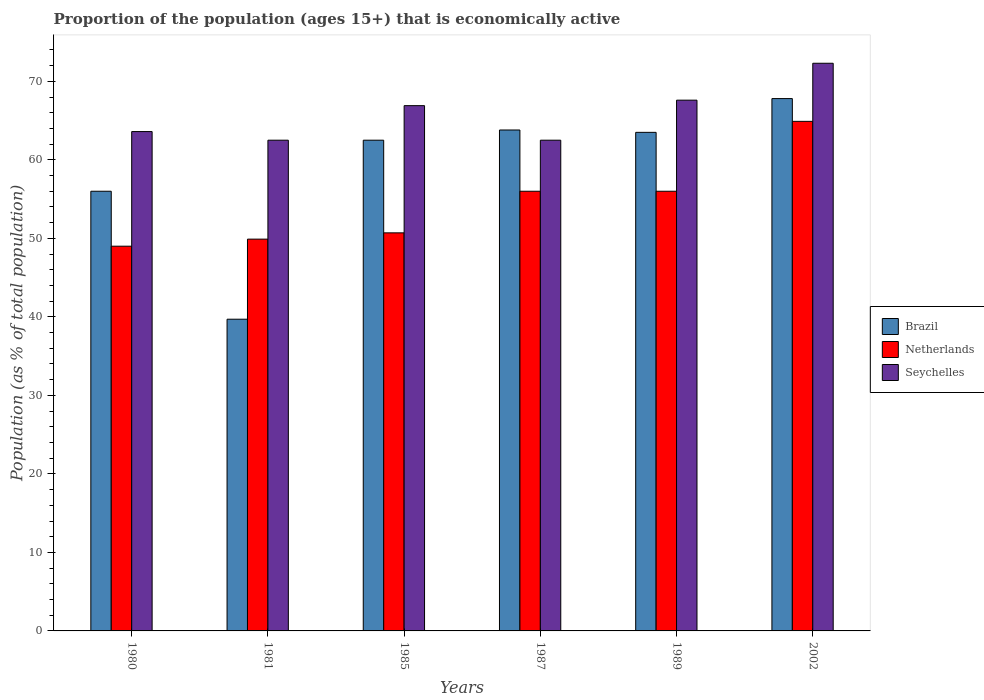How many different coloured bars are there?
Make the answer very short. 3. How many groups of bars are there?
Make the answer very short. 6. Are the number of bars per tick equal to the number of legend labels?
Offer a terse response. Yes. How many bars are there on the 3rd tick from the left?
Give a very brief answer. 3. How many bars are there on the 6th tick from the right?
Keep it short and to the point. 3. In how many cases, is the number of bars for a given year not equal to the number of legend labels?
Give a very brief answer. 0. What is the proportion of the population that is economically active in Seychelles in 1987?
Your answer should be very brief. 62.5. Across all years, what is the maximum proportion of the population that is economically active in Seychelles?
Provide a succinct answer. 72.3. Across all years, what is the minimum proportion of the population that is economically active in Netherlands?
Offer a terse response. 49. In which year was the proportion of the population that is economically active in Netherlands maximum?
Offer a very short reply. 2002. What is the total proportion of the population that is economically active in Netherlands in the graph?
Offer a terse response. 326.5. What is the difference between the proportion of the population that is economically active in Netherlands in 1980 and that in 1985?
Offer a terse response. -1.7. What is the difference between the proportion of the population that is economically active in Brazil in 1981 and the proportion of the population that is economically active in Netherlands in 2002?
Keep it short and to the point. -25.2. What is the average proportion of the population that is economically active in Brazil per year?
Give a very brief answer. 58.88. In the year 2002, what is the difference between the proportion of the population that is economically active in Seychelles and proportion of the population that is economically active in Brazil?
Ensure brevity in your answer.  4.5. In how many years, is the proportion of the population that is economically active in Brazil greater than 50 %?
Ensure brevity in your answer.  5. Is the difference between the proportion of the population that is economically active in Seychelles in 1980 and 1981 greater than the difference between the proportion of the population that is economically active in Brazil in 1980 and 1981?
Provide a succinct answer. No. What is the difference between the highest and the second highest proportion of the population that is economically active in Seychelles?
Your answer should be very brief. 4.7. What is the difference between the highest and the lowest proportion of the population that is economically active in Netherlands?
Provide a short and direct response. 15.9. In how many years, is the proportion of the population that is economically active in Netherlands greater than the average proportion of the population that is economically active in Netherlands taken over all years?
Your answer should be very brief. 3. Is the sum of the proportion of the population that is economically active in Brazil in 1985 and 1989 greater than the maximum proportion of the population that is economically active in Seychelles across all years?
Offer a terse response. Yes. What does the 3rd bar from the left in 1985 represents?
Offer a very short reply. Seychelles. What does the 2nd bar from the right in 2002 represents?
Keep it short and to the point. Netherlands. Is it the case that in every year, the sum of the proportion of the population that is economically active in Netherlands and proportion of the population that is economically active in Brazil is greater than the proportion of the population that is economically active in Seychelles?
Provide a succinct answer. Yes. How many bars are there?
Your answer should be compact. 18. Are all the bars in the graph horizontal?
Provide a short and direct response. No. What is the difference between two consecutive major ticks on the Y-axis?
Make the answer very short. 10. Does the graph contain any zero values?
Give a very brief answer. No. Does the graph contain grids?
Your response must be concise. No. Where does the legend appear in the graph?
Ensure brevity in your answer.  Center right. How many legend labels are there?
Make the answer very short. 3. What is the title of the graph?
Provide a succinct answer. Proportion of the population (ages 15+) that is economically active. Does "Algeria" appear as one of the legend labels in the graph?
Your response must be concise. No. What is the label or title of the Y-axis?
Give a very brief answer. Population (as % of total population). What is the Population (as % of total population) of Seychelles in 1980?
Your answer should be compact. 63.6. What is the Population (as % of total population) of Brazil in 1981?
Keep it short and to the point. 39.7. What is the Population (as % of total population) in Netherlands in 1981?
Your response must be concise. 49.9. What is the Population (as % of total population) of Seychelles in 1981?
Your answer should be very brief. 62.5. What is the Population (as % of total population) in Brazil in 1985?
Make the answer very short. 62.5. What is the Population (as % of total population) of Netherlands in 1985?
Give a very brief answer. 50.7. What is the Population (as % of total population) of Seychelles in 1985?
Your answer should be very brief. 66.9. What is the Population (as % of total population) in Brazil in 1987?
Your response must be concise. 63.8. What is the Population (as % of total population) in Netherlands in 1987?
Give a very brief answer. 56. What is the Population (as % of total population) in Seychelles in 1987?
Make the answer very short. 62.5. What is the Population (as % of total population) of Brazil in 1989?
Offer a terse response. 63.5. What is the Population (as % of total population) in Netherlands in 1989?
Ensure brevity in your answer.  56. What is the Population (as % of total population) of Seychelles in 1989?
Your response must be concise. 67.6. What is the Population (as % of total population) in Brazil in 2002?
Your answer should be compact. 67.8. What is the Population (as % of total population) in Netherlands in 2002?
Offer a very short reply. 64.9. What is the Population (as % of total population) of Seychelles in 2002?
Your response must be concise. 72.3. Across all years, what is the maximum Population (as % of total population) of Brazil?
Make the answer very short. 67.8. Across all years, what is the maximum Population (as % of total population) of Netherlands?
Your answer should be very brief. 64.9. Across all years, what is the maximum Population (as % of total population) in Seychelles?
Your response must be concise. 72.3. Across all years, what is the minimum Population (as % of total population) of Brazil?
Your response must be concise. 39.7. Across all years, what is the minimum Population (as % of total population) in Seychelles?
Your answer should be compact. 62.5. What is the total Population (as % of total population) of Brazil in the graph?
Keep it short and to the point. 353.3. What is the total Population (as % of total population) in Netherlands in the graph?
Provide a short and direct response. 326.5. What is the total Population (as % of total population) of Seychelles in the graph?
Your answer should be compact. 395.4. What is the difference between the Population (as % of total population) in Brazil in 1980 and that in 1981?
Give a very brief answer. 16.3. What is the difference between the Population (as % of total population) in Netherlands in 1980 and that in 1981?
Offer a terse response. -0.9. What is the difference between the Population (as % of total population) in Seychelles in 1980 and that in 1981?
Offer a terse response. 1.1. What is the difference between the Population (as % of total population) of Brazil in 1980 and that in 1985?
Make the answer very short. -6.5. What is the difference between the Population (as % of total population) of Netherlands in 1980 and that in 1985?
Make the answer very short. -1.7. What is the difference between the Population (as % of total population) in Seychelles in 1980 and that in 1985?
Provide a succinct answer. -3.3. What is the difference between the Population (as % of total population) of Brazil in 1980 and that in 1987?
Make the answer very short. -7.8. What is the difference between the Population (as % of total population) in Brazil in 1980 and that in 1989?
Give a very brief answer. -7.5. What is the difference between the Population (as % of total population) of Netherlands in 1980 and that in 1989?
Offer a very short reply. -7. What is the difference between the Population (as % of total population) in Seychelles in 1980 and that in 1989?
Provide a short and direct response. -4. What is the difference between the Population (as % of total population) of Netherlands in 1980 and that in 2002?
Keep it short and to the point. -15.9. What is the difference between the Population (as % of total population) of Seychelles in 1980 and that in 2002?
Give a very brief answer. -8.7. What is the difference between the Population (as % of total population) of Brazil in 1981 and that in 1985?
Your response must be concise. -22.8. What is the difference between the Population (as % of total population) in Netherlands in 1981 and that in 1985?
Offer a terse response. -0.8. What is the difference between the Population (as % of total population) in Seychelles in 1981 and that in 1985?
Your response must be concise. -4.4. What is the difference between the Population (as % of total population) of Brazil in 1981 and that in 1987?
Ensure brevity in your answer.  -24.1. What is the difference between the Population (as % of total population) of Seychelles in 1981 and that in 1987?
Your answer should be very brief. 0. What is the difference between the Population (as % of total population) of Brazil in 1981 and that in 1989?
Your answer should be very brief. -23.8. What is the difference between the Population (as % of total population) of Brazil in 1981 and that in 2002?
Keep it short and to the point. -28.1. What is the difference between the Population (as % of total population) in Netherlands in 1981 and that in 2002?
Provide a short and direct response. -15. What is the difference between the Population (as % of total population) of Seychelles in 1981 and that in 2002?
Ensure brevity in your answer.  -9.8. What is the difference between the Population (as % of total population) in Netherlands in 1985 and that in 1987?
Give a very brief answer. -5.3. What is the difference between the Population (as % of total population) in Seychelles in 1985 and that in 1987?
Offer a terse response. 4.4. What is the difference between the Population (as % of total population) in Brazil in 1985 and that in 1989?
Offer a terse response. -1. What is the difference between the Population (as % of total population) of Netherlands in 1985 and that in 1989?
Give a very brief answer. -5.3. What is the difference between the Population (as % of total population) of Seychelles in 1985 and that in 1989?
Offer a terse response. -0.7. What is the difference between the Population (as % of total population) in Brazil in 1985 and that in 2002?
Your answer should be compact. -5.3. What is the difference between the Population (as % of total population) in Seychelles in 1987 and that in 1989?
Ensure brevity in your answer.  -5.1. What is the difference between the Population (as % of total population) of Seychelles in 1987 and that in 2002?
Offer a very short reply. -9.8. What is the difference between the Population (as % of total population) in Brazil in 1989 and that in 2002?
Your response must be concise. -4.3. What is the difference between the Population (as % of total population) of Netherlands in 1989 and that in 2002?
Make the answer very short. -8.9. What is the difference between the Population (as % of total population) of Seychelles in 1989 and that in 2002?
Provide a short and direct response. -4.7. What is the difference between the Population (as % of total population) of Brazil in 1980 and the Population (as % of total population) of Netherlands in 1981?
Provide a short and direct response. 6.1. What is the difference between the Population (as % of total population) of Netherlands in 1980 and the Population (as % of total population) of Seychelles in 1985?
Your answer should be compact. -17.9. What is the difference between the Population (as % of total population) of Brazil in 1980 and the Population (as % of total population) of Netherlands in 1987?
Make the answer very short. 0. What is the difference between the Population (as % of total population) in Brazil in 1980 and the Population (as % of total population) in Seychelles in 1987?
Keep it short and to the point. -6.5. What is the difference between the Population (as % of total population) of Netherlands in 1980 and the Population (as % of total population) of Seychelles in 1989?
Give a very brief answer. -18.6. What is the difference between the Population (as % of total population) in Brazil in 1980 and the Population (as % of total population) in Netherlands in 2002?
Keep it short and to the point. -8.9. What is the difference between the Population (as % of total population) in Brazil in 1980 and the Population (as % of total population) in Seychelles in 2002?
Offer a terse response. -16.3. What is the difference between the Population (as % of total population) in Netherlands in 1980 and the Population (as % of total population) in Seychelles in 2002?
Keep it short and to the point. -23.3. What is the difference between the Population (as % of total population) in Brazil in 1981 and the Population (as % of total population) in Seychelles in 1985?
Offer a very short reply. -27.2. What is the difference between the Population (as % of total population) of Netherlands in 1981 and the Population (as % of total population) of Seychelles in 1985?
Offer a very short reply. -17. What is the difference between the Population (as % of total population) in Brazil in 1981 and the Population (as % of total population) in Netherlands in 1987?
Your answer should be very brief. -16.3. What is the difference between the Population (as % of total population) of Brazil in 1981 and the Population (as % of total population) of Seychelles in 1987?
Your answer should be very brief. -22.8. What is the difference between the Population (as % of total population) in Brazil in 1981 and the Population (as % of total population) in Netherlands in 1989?
Provide a short and direct response. -16.3. What is the difference between the Population (as % of total population) in Brazil in 1981 and the Population (as % of total population) in Seychelles in 1989?
Your response must be concise. -27.9. What is the difference between the Population (as % of total population) of Netherlands in 1981 and the Population (as % of total population) of Seychelles in 1989?
Provide a succinct answer. -17.7. What is the difference between the Population (as % of total population) of Brazil in 1981 and the Population (as % of total population) of Netherlands in 2002?
Provide a succinct answer. -25.2. What is the difference between the Population (as % of total population) of Brazil in 1981 and the Population (as % of total population) of Seychelles in 2002?
Your answer should be compact. -32.6. What is the difference between the Population (as % of total population) in Netherlands in 1981 and the Population (as % of total population) in Seychelles in 2002?
Your response must be concise. -22.4. What is the difference between the Population (as % of total population) in Brazil in 1985 and the Population (as % of total population) in Netherlands in 1987?
Offer a very short reply. 6.5. What is the difference between the Population (as % of total population) of Brazil in 1985 and the Population (as % of total population) of Netherlands in 1989?
Provide a short and direct response. 6.5. What is the difference between the Population (as % of total population) of Netherlands in 1985 and the Population (as % of total population) of Seychelles in 1989?
Your answer should be compact. -16.9. What is the difference between the Population (as % of total population) in Netherlands in 1985 and the Population (as % of total population) in Seychelles in 2002?
Your answer should be very brief. -21.6. What is the difference between the Population (as % of total population) in Netherlands in 1987 and the Population (as % of total population) in Seychelles in 1989?
Offer a very short reply. -11.6. What is the difference between the Population (as % of total population) in Netherlands in 1987 and the Population (as % of total population) in Seychelles in 2002?
Offer a terse response. -16.3. What is the difference between the Population (as % of total population) in Brazil in 1989 and the Population (as % of total population) in Netherlands in 2002?
Keep it short and to the point. -1.4. What is the difference between the Population (as % of total population) in Brazil in 1989 and the Population (as % of total population) in Seychelles in 2002?
Your answer should be compact. -8.8. What is the difference between the Population (as % of total population) of Netherlands in 1989 and the Population (as % of total population) of Seychelles in 2002?
Your answer should be compact. -16.3. What is the average Population (as % of total population) of Brazil per year?
Ensure brevity in your answer.  58.88. What is the average Population (as % of total population) in Netherlands per year?
Provide a succinct answer. 54.42. What is the average Population (as % of total population) in Seychelles per year?
Ensure brevity in your answer.  65.9. In the year 1980, what is the difference between the Population (as % of total population) of Brazil and Population (as % of total population) of Netherlands?
Offer a very short reply. 7. In the year 1980, what is the difference between the Population (as % of total population) of Netherlands and Population (as % of total population) of Seychelles?
Give a very brief answer. -14.6. In the year 1981, what is the difference between the Population (as % of total population) of Brazil and Population (as % of total population) of Netherlands?
Make the answer very short. -10.2. In the year 1981, what is the difference between the Population (as % of total population) of Brazil and Population (as % of total population) of Seychelles?
Make the answer very short. -22.8. In the year 1981, what is the difference between the Population (as % of total population) of Netherlands and Population (as % of total population) of Seychelles?
Your response must be concise. -12.6. In the year 1985, what is the difference between the Population (as % of total population) in Netherlands and Population (as % of total population) in Seychelles?
Provide a short and direct response. -16.2. In the year 1987, what is the difference between the Population (as % of total population) in Brazil and Population (as % of total population) in Netherlands?
Give a very brief answer. 7.8. In the year 1987, what is the difference between the Population (as % of total population) in Brazil and Population (as % of total population) in Seychelles?
Provide a succinct answer. 1.3. In the year 1987, what is the difference between the Population (as % of total population) in Netherlands and Population (as % of total population) in Seychelles?
Your answer should be compact. -6.5. In the year 1989, what is the difference between the Population (as % of total population) of Brazil and Population (as % of total population) of Seychelles?
Offer a very short reply. -4.1. In the year 2002, what is the difference between the Population (as % of total population) in Brazil and Population (as % of total population) in Netherlands?
Provide a short and direct response. 2.9. What is the ratio of the Population (as % of total population) of Brazil in 1980 to that in 1981?
Your response must be concise. 1.41. What is the ratio of the Population (as % of total population) of Seychelles in 1980 to that in 1981?
Make the answer very short. 1.02. What is the ratio of the Population (as % of total population) of Brazil in 1980 to that in 1985?
Provide a succinct answer. 0.9. What is the ratio of the Population (as % of total population) of Netherlands in 1980 to that in 1985?
Your response must be concise. 0.97. What is the ratio of the Population (as % of total population) in Seychelles in 1980 to that in 1985?
Make the answer very short. 0.95. What is the ratio of the Population (as % of total population) in Brazil in 1980 to that in 1987?
Provide a succinct answer. 0.88. What is the ratio of the Population (as % of total population) of Netherlands in 1980 to that in 1987?
Keep it short and to the point. 0.88. What is the ratio of the Population (as % of total population) of Seychelles in 1980 to that in 1987?
Provide a short and direct response. 1.02. What is the ratio of the Population (as % of total population) in Brazil in 1980 to that in 1989?
Your response must be concise. 0.88. What is the ratio of the Population (as % of total population) in Netherlands in 1980 to that in 1989?
Make the answer very short. 0.88. What is the ratio of the Population (as % of total population) in Seychelles in 1980 to that in 1989?
Keep it short and to the point. 0.94. What is the ratio of the Population (as % of total population) in Brazil in 1980 to that in 2002?
Ensure brevity in your answer.  0.83. What is the ratio of the Population (as % of total population) in Netherlands in 1980 to that in 2002?
Offer a terse response. 0.76. What is the ratio of the Population (as % of total population) of Seychelles in 1980 to that in 2002?
Ensure brevity in your answer.  0.88. What is the ratio of the Population (as % of total population) of Brazil in 1981 to that in 1985?
Offer a terse response. 0.64. What is the ratio of the Population (as % of total population) of Netherlands in 1981 to that in 1985?
Provide a succinct answer. 0.98. What is the ratio of the Population (as % of total population) of Seychelles in 1981 to that in 1985?
Provide a short and direct response. 0.93. What is the ratio of the Population (as % of total population) in Brazil in 1981 to that in 1987?
Your answer should be compact. 0.62. What is the ratio of the Population (as % of total population) in Netherlands in 1981 to that in 1987?
Give a very brief answer. 0.89. What is the ratio of the Population (as % of total population) of Brazil in 1981 to that in 1989?
Keep it short and to the point. 0.63. What is the ratio of the Population (as % of total population) in Netherlands in 1981 to that in 1989?
Give a very brief answer. 0.89. What is the ratio of the Population (as % of total population) in Seychelles in 1981 to that in 1989?
Your response must be concise. 0.92. What is the ratio of the Population (as % of total population) of Brazil in 1981 to that in 2002?
Ensure brevity in your answer.  0.59. What is the ratio of the Population (as % of total population) of Netherlands in 1981 to that in 2002?
Your response must be concise. 0.77. What is the ratio of the Population (as % of total population) in Seychelles in 1981 to that in 2002?
Make the answer very short. 0.86. What is the ratio of the Population (as % of total population) of Brazil in 1985 to that in 1987?
Make the answer very short. 0.98. What is the ratio of the Population (as % of total population) of Netherlands in 1985 to that in 1987?
Your answer should be very brief. 0.91. What is the ratio of the Population (as % of total population) of Seychelles in 1985 to that in 1987?
Your answer should be compact. 1.07. What is the ratio of the Population (as % of total population) of Brazil in 1985 to that in 1989?
Offer a very short reply. 0.98. What is the ratio of the Population (as % of total population) in Netherlands in 1985 to that in 1989?
Ensure brevity in your answer.  0.91. What is the ratio of the Population (as % of total population) in Seychelles in 1985 to that in 1989?
Offer a very short reply. 0.99. What is the ratio of the Population (as % of total population) of Brazil in 1985 to that in 2002?
Provide a short and direct response. 0.92. What is the ratio of the Population (as % of total population) in Netherlands in 1985 to that in 2002?
Ensure brevity in your answer.  0.78. What is the ratio of the Population (as % of total population) in Seychelles in 1985 to that in 2002?
Give a very brief answer. 0.93. What is the ratio of the Population (as % of total population) in Seychelles in 1987 to that in 1989?
Offer a terse response. 0.92. What is the ratio of the Population (as % of total population) in Brazil in 1987 to that in 2002?
Your answer should be very brief. 0.94. What is the ratio of the Population (as % of total population) in Netherlands in 1987 to that in 2002?
Offer a very short reply. 0.86. What is the ratio of the Population (as % of total population) in Seychelles in 1987 to that in 2002?
Your answer should be very brief. 0.86. What is the ratio of the Population (as % of total population) in Brazil in 1989 to that in 2002?
Your answer should be compact. 0.94. What is the ratio of the Population (as % of total population) of Netherlands in 1989 to that in 2002?
Your answer should be very brief. 0.86. What is the ratio of the Population (as % of total population) in Seychelles in 1989 to that in 2002?
Your answer should be compact. 0.94. What is the difference between the highest and the second highest Population (as % of total population) in Seychelles?
Ensure brevity in your answer.  4.7. What is the difference between the highest and the lowest Population (as % of total population) in Brazil?
Your response must be concise. 28.1. What is the difference between the highest and the lowest Population (as % of total population) of Netherlands?
Provide a succinct answer. 15.9. 